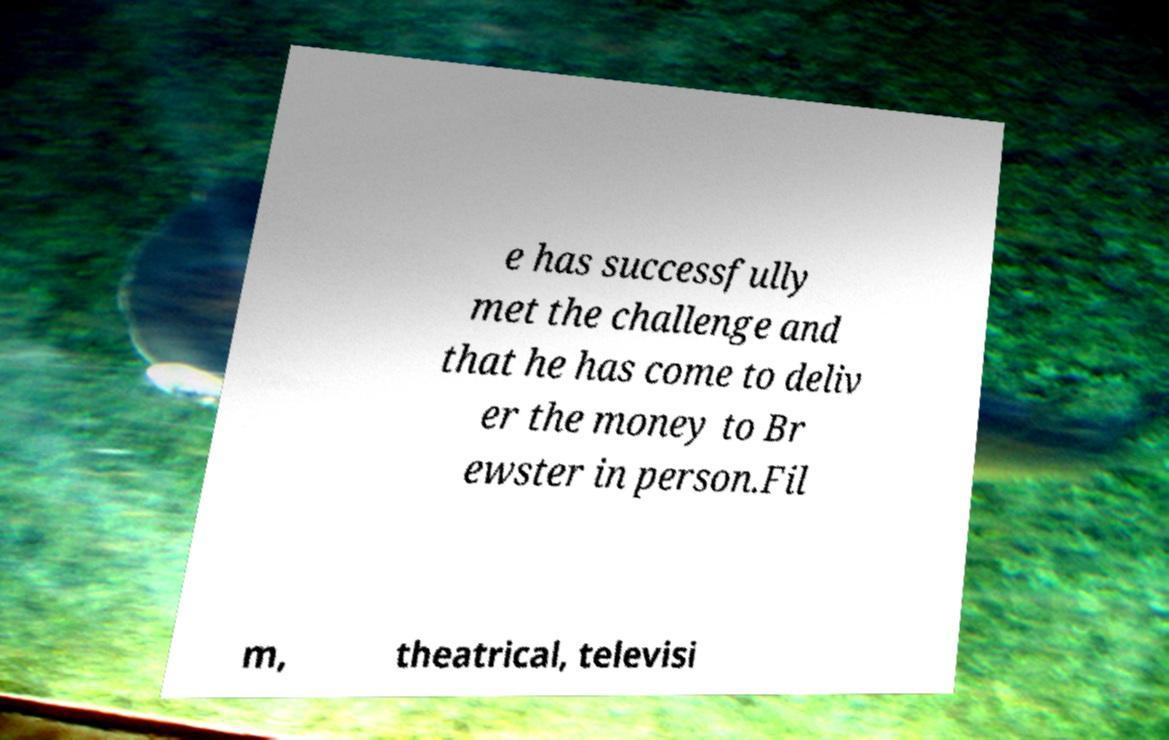Can you read and provide the text displayed in the image?This photo seems to have some interesting text. Can you extract and type it out for me? e has successfully met the challenge and that he has come to deliv er the money to Br ewster in person.Fil m, theatrical, televisi 